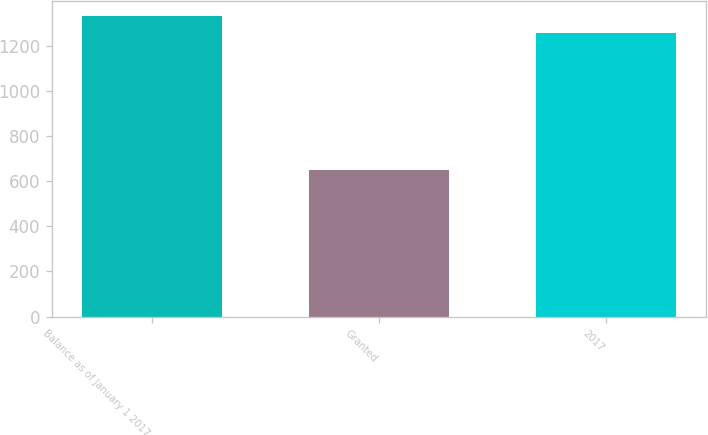Convert chart to OTSL. <chart><loc_0><loc_0><loc_500><loc_500><bar_chart><fcel>Balance as of January 1 2017<fcel>Granted<fcel>2017<nl><fcel>1333<fcel>650<fcel>1257<nl></chart> 